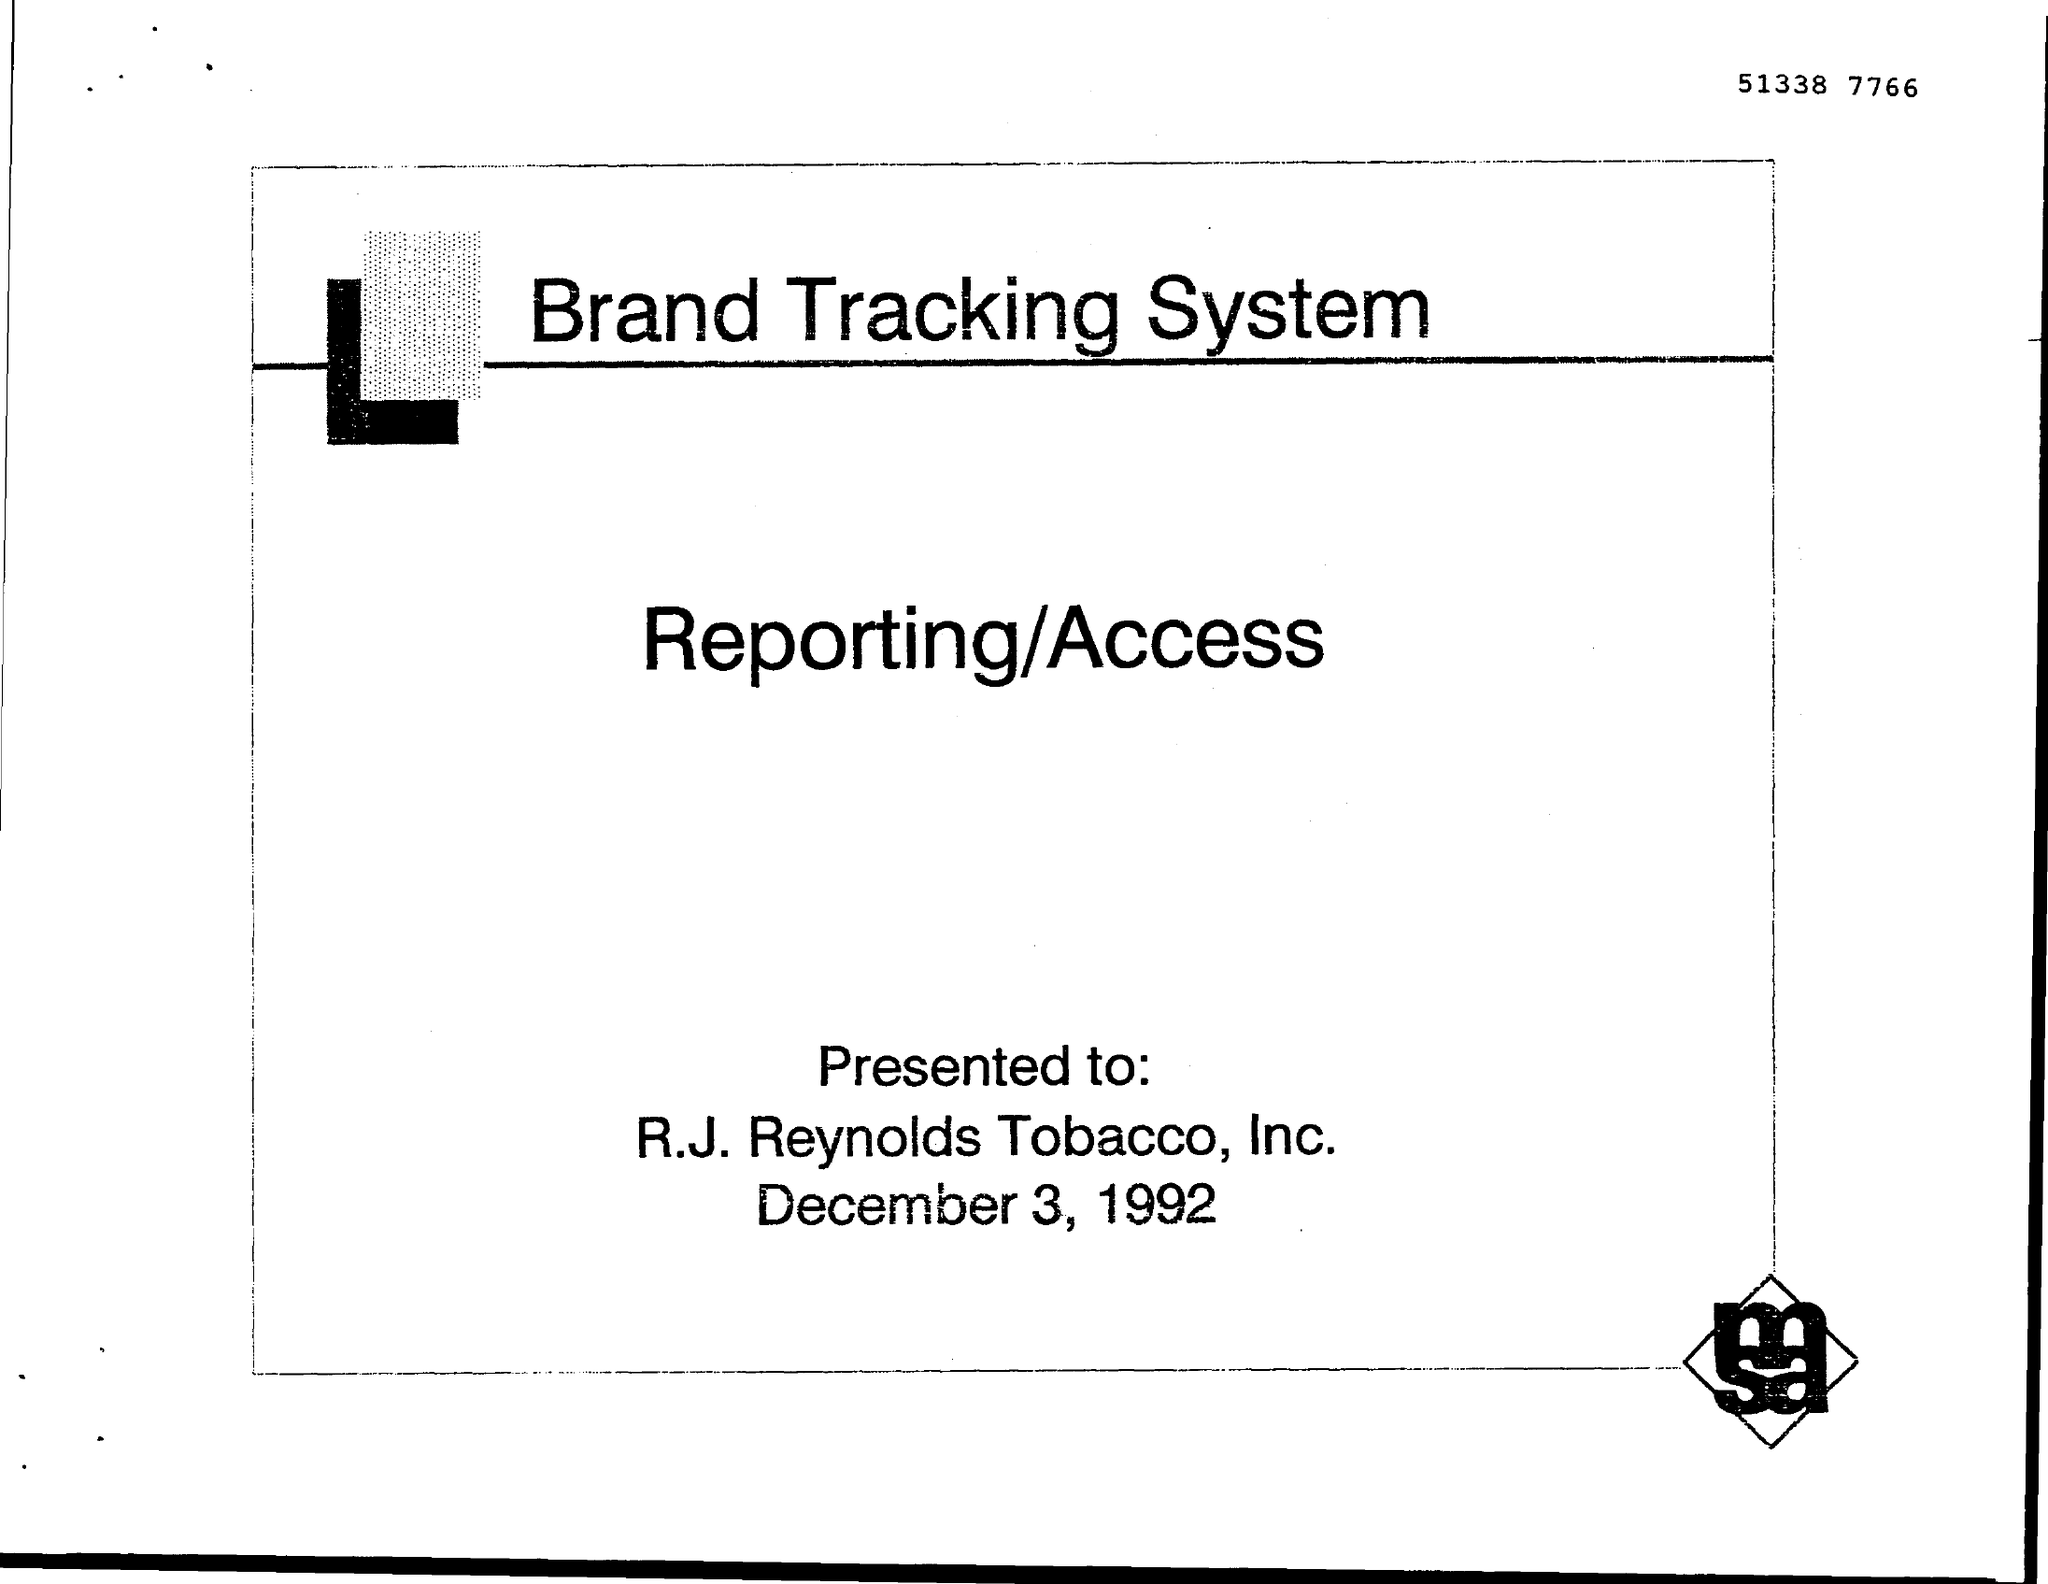What is the Title of the document?
Make the answer very short. Brand Tracking System. Who is this Presented to?
Your answer should be very brief. R. J. Reynolds Tobacco, Inc. What is the Date?
Offer a very short reply. December 3, 1992. What is the Document Number?
Give a very brief answer. 51338 7766. 